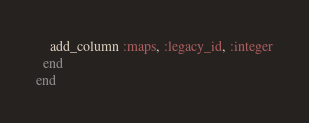<code> <loc_0><loc_0><loc_500><loc_500><_Ruby_>    add_column :maps, :legacy_id, :integer
  end
end
</code> 